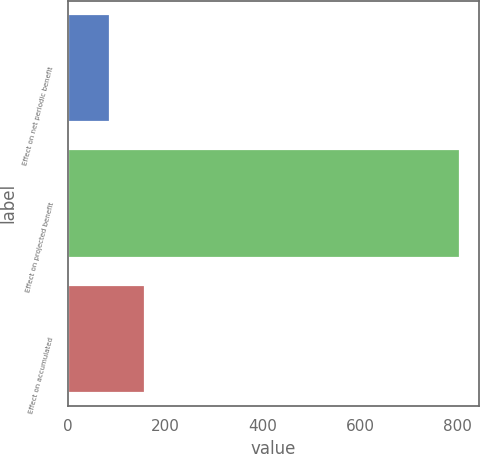<chart> <loc_0><loc_0><loc_500><loc_500><bar_chart><fcel>Effect on net periodic benefit<fcel>Effect on projected benefit<fcel>Effect on accumulated<nl><fcel>86<fcel>805<fcel>157.9<nl></chart> 